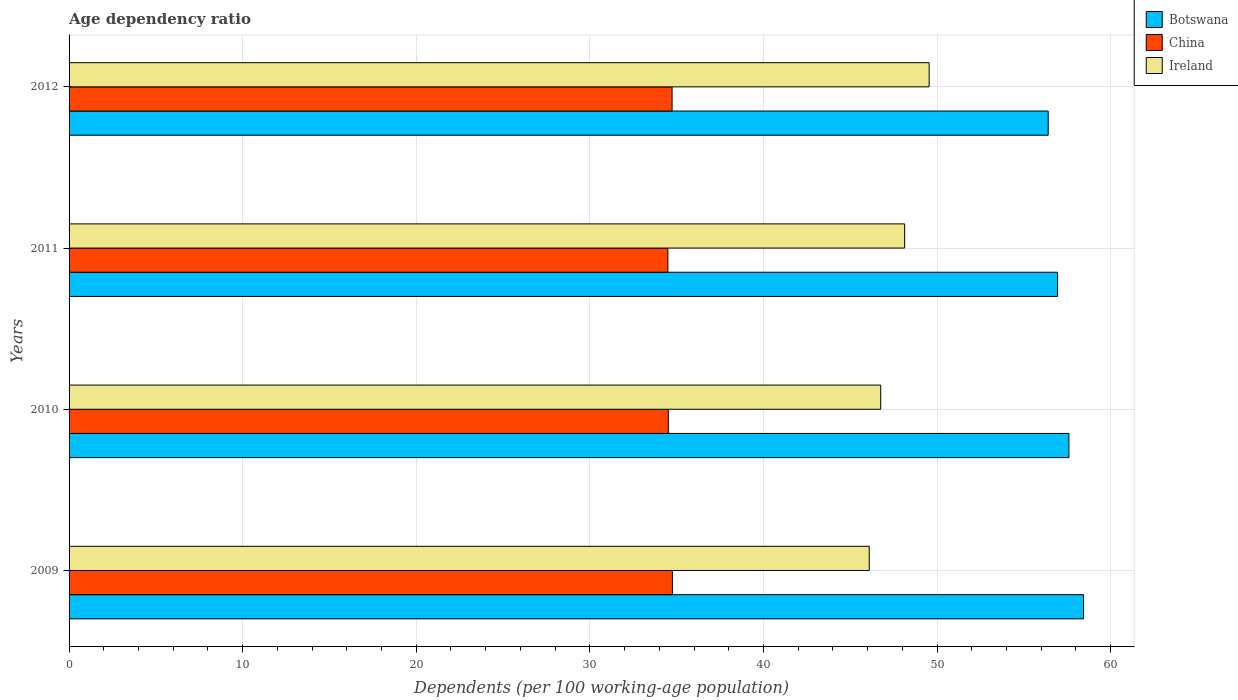How many different coloured bars are there?
Your answer should be very brief. 3. How many groups of bars are there?
Your answer should be compact. 4. Are the number of bars on each tick of the Y-axis equal?
Your answer should be very brief. Yes. How many bars are there on the 1st tick from the top?
Offer a terse response. 3. What is the age dependency ratio in in Ireland in 2012?
Provide a succinct answer. 49.55. Across all years, what is the maximum age dependency ratio in in China?
Give a very brief answer. 34.76. Across all years, what is the minimum age dependency ratio in in China?
Your answer should be compact. 34.49. In which year was the age dependency ratio in in China maximum?
Your answer should be compact. 2009. In which year was the age dependency ratio in in Ireland minimum?
Provide a short and direct response. 2009. What is the total age dependency ratio in in China in the graph?
Keep it short and to the point. 138.51. What is the difference between the age dependency ratio in in Ireland in 2009 and that in 2011?
Keep it short and to the point. -2.04. What is the difference between the age dependency ratio in in Ireland in 2011 and the age dependency ratio in in Botswana in 2012?
Ensure brevity in your answer.  -8.27. What is the average age dependency ratio in in China per year?
Offer a very short reply. 34.63. In the year 2010, what is the difference between the age dependency ratio in in Ireland and age dependency ratio in in China?
Provide a succinct answer. 12.24. What is the ratio of the age dependency ratio in in Ireland in 2009 to that in 2010?
Provide a short and direct response. 0.99. Is the age dependency ratio in in China in 2010 less than that in 2012?
Make the answer very short. Yes. What is the difference between the highest and the second highest age dependency ratio in in Botswana?
Provide a short and direct response. 0.84. What is the difference between the highest and the lowest age dependency ratio in in Botswana?
Your response must be concise. 2.03. Is the sum of the age dependency ratio in in China in 2011 and 2012 greater than the maximum age dependency ratio in in Ireland across all years?
Keep it short and to the point. Yes. What does the 3rd bar from the top in 2012 represents?
Offer a very short reply. Botswana. What does the 2nd bar from the bottom in 2009 represents?
Offer a very short reply. China. Is it the case that in every year, the sum of the age dependency ratio in in Ireland and age dependency ratio in in China is greater than the age dependency ratio in in Botswana?
Make the answer very short. Yes. Are all the bars in the graph horizontal?
Your response must be concise. Yes. How many years are there in the graph?
Give a very brief answer. 4. Does the graph contain any zero values?
Offer a terse response. No. Where does the legend appear in the graph?
Your response must be concise. Top right. What is the title of the graph?
Give a very brief answer. Age dependency ratio. What is the label or title of the X-axis?
Offer a terse response. Dependents (per 100 working-age population). What is the Dependents (per 100 working-age population) in Botswana in 2009?
Provide a short and direct response. 58.44. What is the Dependents (per 100 working-age population) in China in 2009?
Offer a terse response. 34.76. What is the Dependents (per 100 working-age population) of Ireland in 2009?
Offer a very short reply. 46.1. What is the Dependents (per 100 working-age population) in Botswana in 2010?
Give a very brief answer. 57.6. What is the Dependents (per 100 working-age population) in China in 2010?
Offer a terse response. 34.52. What is the Dependents (per 100 working-age population) in Ireland in 2010?
Offer a terse response. 46.76. What is the Dependents (per 100 working-age population) of Botswana in 2011?
Your answer should be compact. 56.94. What is the Dependents (per 100 working-age population) of China in 2011?
Give a very brief answer. 34.49. What is the Dependents (per 100 working-age population) in Ireland in 2011?
Offer a very short reply. 48.14. What is the Dependents (per 100 working-age population) of Botswana in 2012?
Make the answer very short. 56.4. What is the Dependents (per 100 working-age population) in China in 2012?
Offer a terse response. 34.74. What is the Dependents (per 100 working-age population) of Ireland in 2012?
Your response must be concise. 49.55. Across all years, what is the maximum Dependents (per 100 working-age population) in Botswana?
Give a very brief answer. 58.44. Across all years, what is the maximum Dependents (per 100 working-age population) in China?
Offer a very short reply. 34.76. Across all years, what is the maximum Dependents (per 100 working-age population) in Ireland?
Provide a succinct answer. 49.55. Across all years, what is the minimum Dependents (per 100 working-age population) of Botswana?
Keep it short and to the point. 56.4. Across all years, what is the minimum Dependents (per 100 working-age population) of China?
Offer a very short reply. 34.49. Across all years, what is the minimum Dependents (per 100 working-age population) in Ireland?
Offer a terse response. 46.1. What is the total Dependents (per 100 working-age population) of Botswana in the graph?
Your answer should be compact. 229.38. What is the total Dependents (per 100 working-age population) in China in the graph?
Your answer should be very brief. 138.51. What is the total Dependents (per 100 working-age population) in Ireland in the graph?
Make the answer very short. 190.54. What is the difference between the Dependents (per 100 working-age population) in Botswana in 2009 and that in 2010?
Make the answer very short. 0.84. What is the difference between the Dependents (per 100 working-age population) in China in 2009 and that in 2010?
Give a very brief answer. 0.24. What is the difference between the Dependents (per 100 working-age population) in Ireland in 2009 and that in 2010?
Give a very brief answer. -0.66. What is the difference between the Dependents (per 100 working-age population) in Botswana in 2009 and that in 2011?
Make the answer very short. 1.5. What is the difference between the Dependents (per 100 working-age population) in China in 2009 and that in 2011?
Make the answer very short. 0.26. What is the difference between the Dependents (per 100 working-age population) in Ireland in 2009 and that in 2011?
Provide a short and direct response. -2.04. What is the difference between the Dependents (per 100 working-age population) in Botswana in 2009 and that in 2012?
Your answer should be compact. 2.03. What is the difference between the Dependents (per 100 working-age population) in China in 2009 and that in 2012?
Keep it short and to the point. 0.02. What is the difference between the Dependents (per 100 working-age population) of Ireland in 2009 and that in 2012?
Give a very brief answer. -3.45. What is the difference between the Dependents (per 100 working-age population) of Botswana in 2010 and that in 2011?
Your answer should be very brief. 0.65. What is the difference between the Dependents (per 100 working-age population) in China in 2010 and that in 2011?
Give a very brief answer. 0.03. What is the difference between the Dependents (per 100 working-age population) of Ireland in 2010 and that in 2011?
Your answer should be compact. -1.38. What is the difference between the Dependents (per 100 working-age population) in Botswana in 2010 and that in 2012?
Make the answer very short. 1.19. What is the difference between the Dependents (per 100 working-age population) in China in 2010 and that in 2012?
Keep it short and to the point. -0.22. What is the difference between the Dependents (per 100 working-age population) of Ireland in 2010 and that in 2012?
Your response must be concise. -2.79. What is the difference between the Dependents (per 100 working-age population) in Botswana in 2011 and that in 2012?
Your answer should be very brief. 0.54. What is the difference between the Dependents (per 100 working-age population) in China in 2011 and that in 2012?
Give a very brief answer. -0.24. What is the difference between the Dependents (per 100 working-age population) of Ireland in 2011 and that in 2012?
Provide a short and direct response. -1.41. What is the difference between the Dependents (per 100 working-age population) of Botswana in 2009 and the Dependents (per 100 working-age population) of China in 2010?
Your answer should be very brief. 23.92. What is the difference between the Dependents (per 100 working-age population) in Botswana in 2009 and the Dependents (per 100 working-age population) in Ireland in 2010?
Offer a terse response. 11.68. What is the difference between the Dependents (per 100 working-age population) in China in 2009 and the Dependents (per 100 working-age population) in Ireland in 2010?
Give a very brief answer. -12. What is the difference between the Dependents (per 100 working-age population) in Botswana in 2009 and the Dependents (per 100 working-age population) in China in 2011?
Your answer should be very brief. 23.95. What is the difference between the Dependents (per 100 working-age population) of Botswana in 2009 and the Dependents (per 100 working-age population) of Ireland in 2011?
Make the answer very short. 10.3. What is the difference between the Dependents (per 100 working-age population) of China in 2009 and the Dependents (per 100 working-age population) of Ireland in 2011?
Keep it short and to the point. -13.38. What is the difference between the Dependents (per 100 working-age population) in Botswana in 2009 and the Dependents (per 100 working-age population) in China in 2012?
Ensure brevity in your answer.  23.7. What is the difference between the Dependents (per 100 working-age population) in Botswana in 2009 and the Dependents (per 100 working-age population) in Ireland in 2012?
Your response must be concise. 8.89. What is the difference between the Dependents (per 100 working-age population) of China in 2009 and the Dependents (per 100 working-age population) of Ireland in 2012?
Provide a succinct answer. -14.79. What is the difference between the Dependents (per 100 working-age population) in Botswana in 2010 and the Dependents (per 100 working-age population) in China in 2011?
Give a very brief answer. 23.1. What is the difference between the Dependents (per 100 working-age population) in Botswana in 2010 and the Dependents (per 100 working-age population) in Ireland in 2011?
Ensure brevity in your answer.  9.46. What is the difference between the Dependents (per 100 working-age population) in China in 2010 and the Dependents (per 100 working-age population) in Ireland in 2011?
Your answer should be very brief. -13.62. What is the difference between the Dependents (per 100 working-age population) of Botswana in 2010 and the Dependents (per 100 working-age population) of China in 2012?
Your answer should be compact. 22.86. What is the difference between the Dependents (per 100 working-age population) in Botswana in 2010 and the Dependents (per 100 working-age population) in Ireland in 2012?
Offer a very short reply. 8.05. What is the difference between the Dependents (per 100 working-age population) of China in 2010 and the Dependents (per 100 working-age population) of Ireland in 2012?
Provide a succinct answer. -15.03. What is the difference between the Dependents (per 100 working-age population) in Botswana in 2011 and the Dependents (per 100 working-age population) in China in 2012?
Offer a terse response. 22.21. What is the difference between the Dependents (per 100 working-age population) in Botswana in 2011 and the Dependents (per 100 working-age population) in Ireland in 2012?
Make the answer very short. 7.4. What is the difference between the Dependents (per 100 working-age population) in China in 2011 and the Dependents (per 100 working-age population) in Ireland in 2012?
Provide a succinct answer. -15.05. What is the average Dependents (per 100 working-age population) of Botswana per year?
Give a very brief answer. 57.35. What is the average Dependents (per 100 working-age population) of China per year?
Offer a terse response. 34.63. What is the average Dependents (per 100 working-age population) of Ireland per year?
Offer a very short reply. 47.63. In the year 2009, what is the difference between the Dependents (per 100 working-age population) of Botswana and Dependents (per 100 working-age population) of China?
Give a very brief answer. 23.68. In the year 2009, what is the difference between the Dependents (per 100 working-age population) in Botswana and Dependents (per 100 working-age population) in Ireland?
Give a very brief answer. 12.34. In the year 2009, what is the difference between the Dependents (per 100 working-age population) in China and Dependents (per 100 working-age population) in Ireland?
Your response must be concise. -11.34. In the year 2010, what is the difference between the Dependents (per 100 working-age population) of Botswana and Dependents (per 100 working-age population) of China?
Keep it short and to the point. 23.08. In the year 2010, what is the difference between the Dependents (per 100 working-age population) of Botswana and Dependents (per 100 working-age population) of Ireland?
Provide a short and direct response. 10.84. In the year 2010, what is the difference between the Dependents (per 100 working-age population) in China and Dependents (per 100 working-age population) in Ireland?
Your response must be concise. -12.24. In the year 2011, what is the difference between the Dependents (per 100 working-age population) of Botswana and Dependents (per 100 working-age population) of China?
Ensure brevity in your answer.  22.45. In the year 2011, what is the difference between the Dependents (per 100 working-age population) of Botswana and Dependents (per 100 working-age population) of Ireland?
Your response must be concise. 8.81. In the year 2011, what is the difference between the Dependents (per 100 working-age population) in China and Dependents (per 100 working-age population) in Ireland?
Your answer should be very brief. -13.64. In the year 2012, what is the difference between the Dependents (per 100 working-age population) in Botswana and Dependents (per 100 working-age population) in China?
Offer a very short reply. 21.67. In the year 2012, what is the difference between the Dependents (per 100 working-age population) of Botswana and Dependents (per 100 working-age population) of Ireland?
Your answer should be compact. 6.86. In the year 2012, what is the difference between the Dependents (per 100 working-age population) in China and Dependents (per 100 working-age population) in Ireland?
Keep it short and to the point. -14.81. What is the ratio of the Dependents (per 100 working-age population) in Botswana in 2009 to that in 2010?
Your response must be concise. 1.01. What is the ratio of the Dependents (per 100 working-age population) of China in 2009 to that in 2010?
Your response must be concise. 1.01. What is the ratio of the Dependents (per 100 working-age population) of Ireland in 2009 to that in 2010?
Give a very brief answer. 0.99. What is the ratio of the Dependents (per 100 working-age population) in Botswana in 2009 to that in 2011?
Your answer should be compact. 1.03. What is the ratio of the Dependents (per 100 working-age population) of China in 2009 to that in 2011?
Your answer should be compact. 1.01. What is the ratio of the Dependents (per 100 working-age population) in Ireland in 2009 to that in 2011?
Your response must be concise. 0.96. What is the ratio of the Dependents (per 100 working-age population) in Botswana in 2009 to that in 2012?
Provide a succinct answer. 1.04. What is the ratio of the Dependents (per 100 working-age population) of Ireland in 2009 to that in 2012?
Provide a succinct answer. 0.93. What is the ratio of the Dependents (per 100 working-age population) of Botswana in 2010 to that in 2011?
Offer a terse response. 1.01. What is the ratio of the Dependents (per 100 working-age population) of Ireland in 2010 to that in 2011?
Give a very brief answer. 0.97. What is the ratio of the Dependents (per 100 working-age population) in Botswana in 2010 to that in 2012?
Offer a terse response. 1.02. What is the ratio of the Dependents (per 100 working-age population) of Ireland in 2010 to that in 2012?
Your response must be concise. 0.94. What is the ratio of the Dependents (per 100 working-age population) in Botswana in 2011 to that in 2012?
Your response must be concise. 1.01. What is the ratio of the Dependents (per 100 working-age population) of Ireland in 2011 to that in 2012?
Give a very brief answer. 0.97. What is the difference between the highest and the second highest Dependents (per 100 working-age population) in Botswana?
Your answer should be compact. 0.84. What is the difference between the highest and the second highest Dependents (per 100 working-age population) of China?
Give a very brief answer. 0.02. What is the difference between the highest and the second highest Dependents (per 100 working-age population) of Ireland?
Provide a short and direct response. 1.41. What is the difference between the highest and the lowest Dependents (per 100 working-age population) of Botswana?
Provide a short and direct response. 2.03. What is the difference between the highest and the lowest Dependents (per 100 working-age population) of China?
Give a very brief answer. 0.26. What is the difference between the highest and the lowest Dependents (per 100 working-age population) of Ireland?
Ensure brevity in your answer.  3.45. 